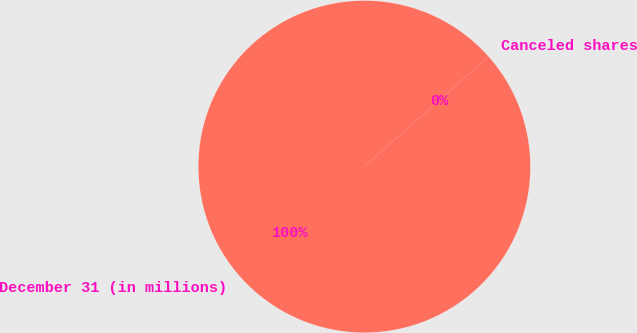Convert chart to OTSL. <chart><loc_0><loc_0><loc_500><loc_500><pie_chart><fcel>December 31 (in millions)<fcel>Canceled shares<nl><fcel>100.0%<fcel>0.0%<nl></chart> 